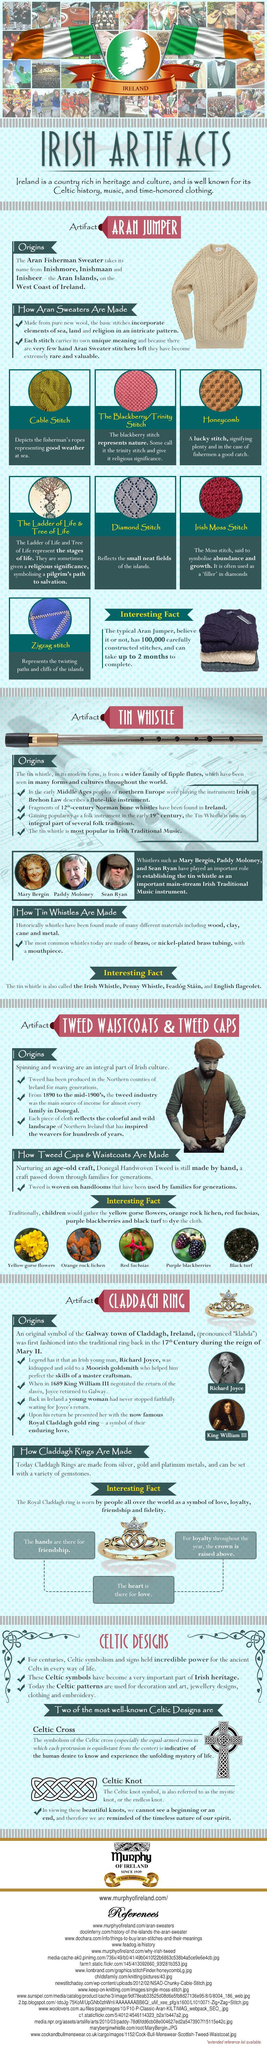Highlight a few significant elements in this photo. The honeycomb stitch symbolizes a successful fishing trip for the fishermen, indicating a bountiful catch. The zigzag stitch represents the twisting paths and cliffs of the islands, showcasing the rugged beauty of the landscape. The Diamond Stitch is the stitch that reflects the small, neat fields of the islands. The cable stitch is a symbol of a favorable weather condition for fishermen while at sea. 